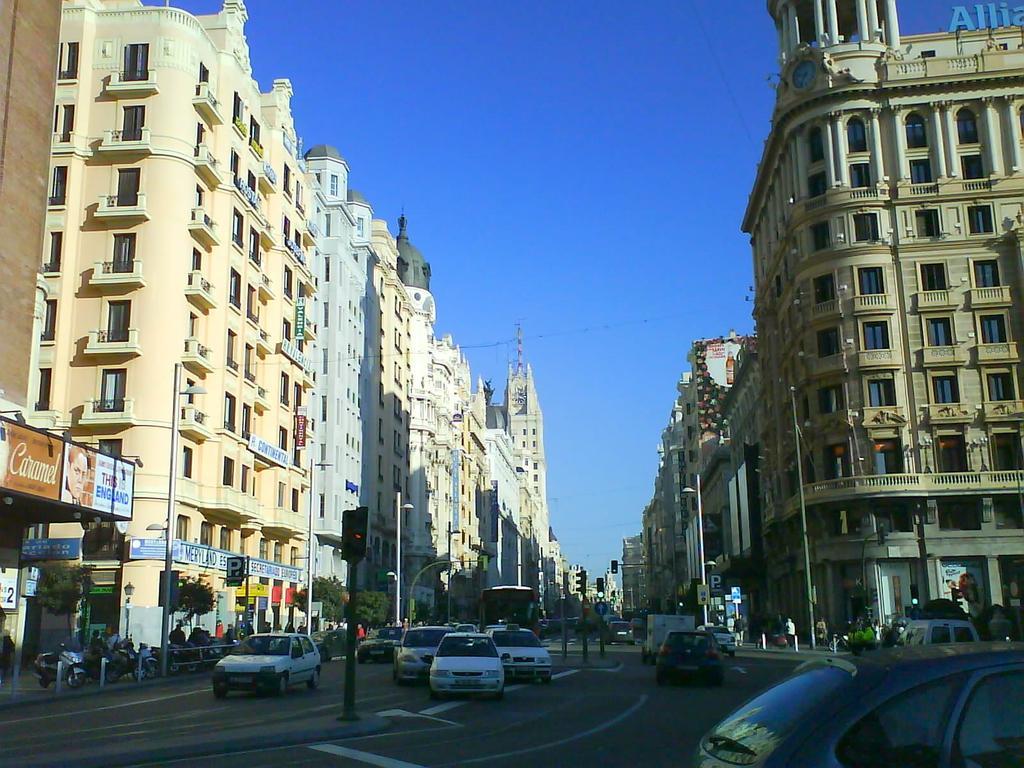Can you describe this image briefly? In this image I can see buildings. There are vehicles, poles, lights, trees, name boards and in the background there is sky. 